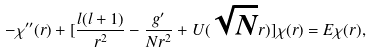Convert formula to latex. <formula><loc_0><loc_0><loc_500><loc_500>- \chi ^ { \prime \prime } ( r ) + [ \frac { l ( l + 1 ) } { r ^ { 2 } } - \frac { g ^ { \prime } } { N r ^ { 2 } } + U ( \sqrt { N } r ) ] \chi ( r ) = E \chi ( r ) ,</formula> 